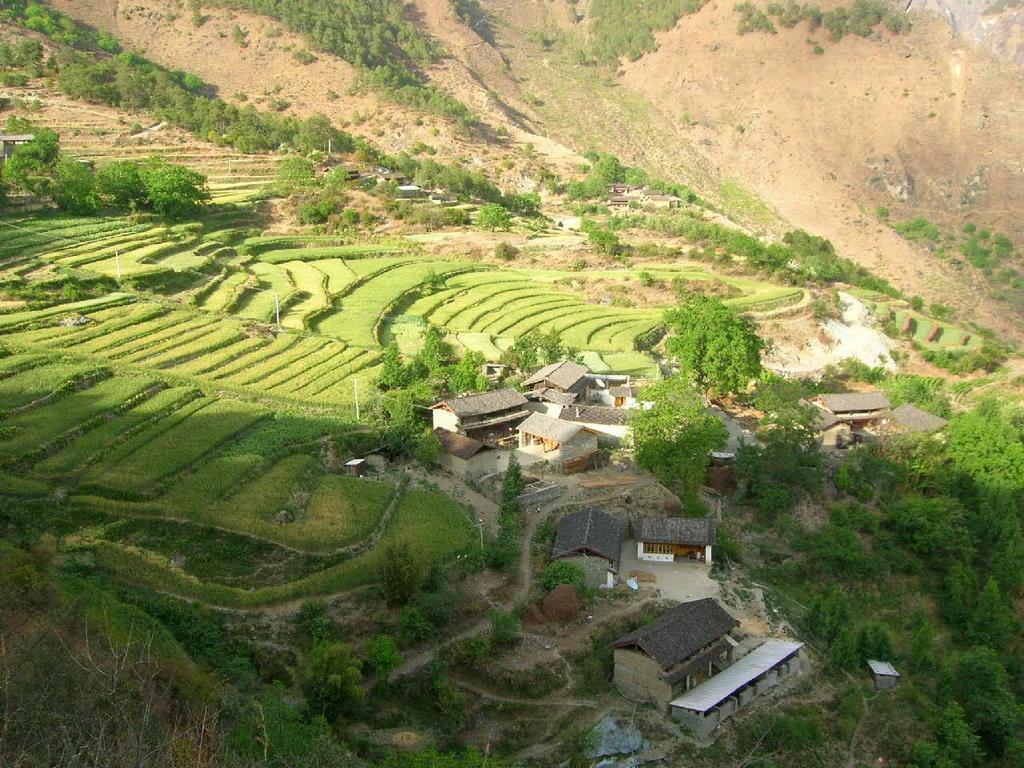Describe this image in one or two sentences. In this image I can see houses, trees, farms and mountains. This image is taken may be near the mountains. 